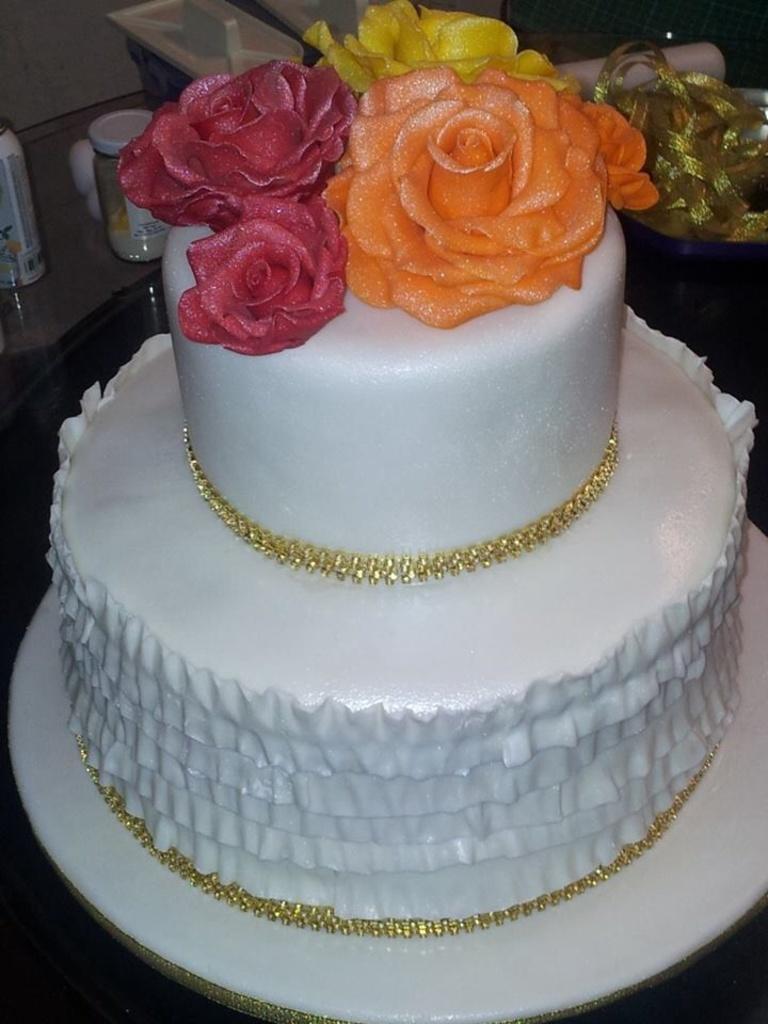Describe this image in one or two sentences. In this image we can see there is a cake and some other objects. 